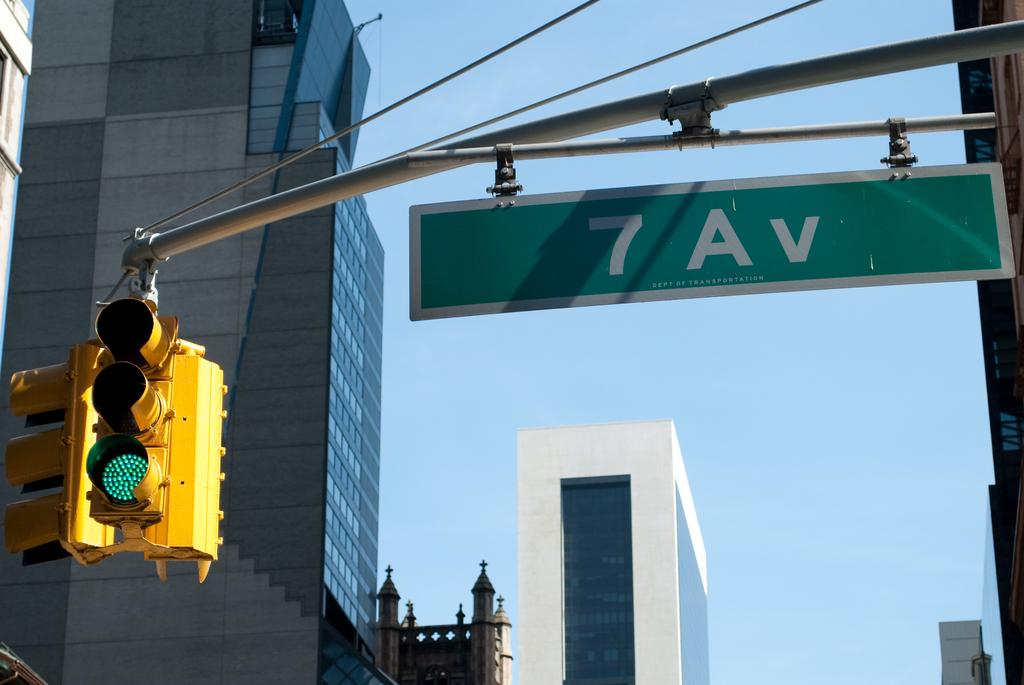<image>
Give a short and clear explanation of the subsequent image. The street light suspended to the left of the 7th Avenue street sign is green. 